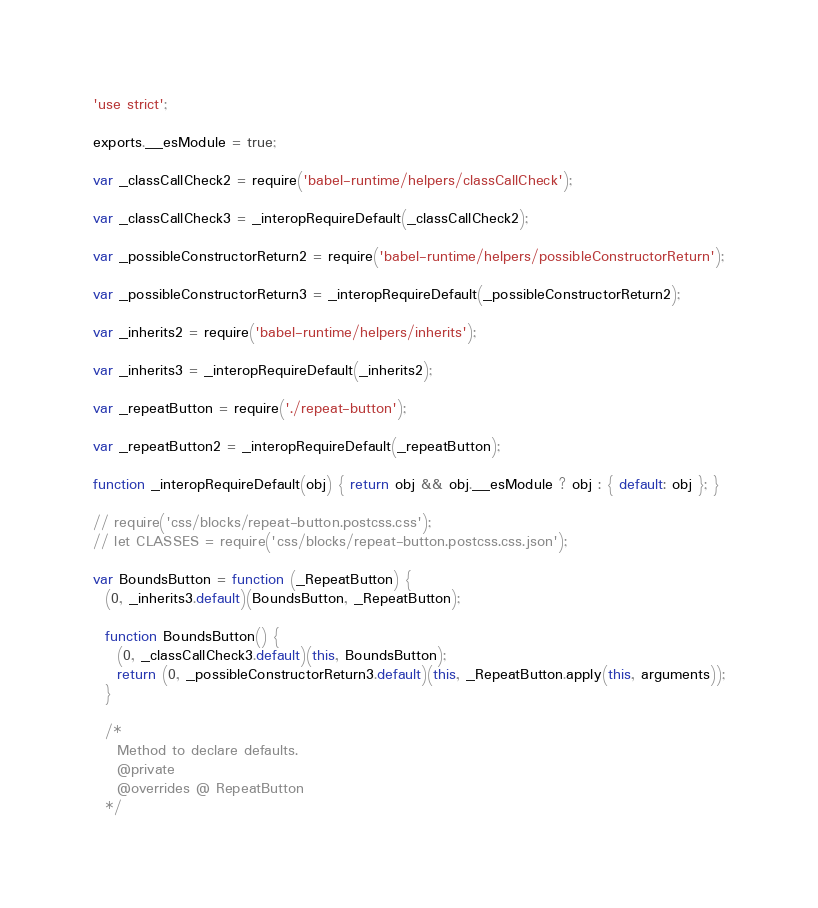Convert code to text. <code><loc_0><loc_0><loc_500><loc_500><_JavaScript_>'use strict';

exports.__esModule = true;

var _classCallCheck2 = require('babel-runtime/helpers/classCallCheck');

var _classCallCheck3 = _interopRequireDefault(_classCallCheck2);

var _possibleConstructorReturn2 = require('babel-runtime/helpers/possibleConstructorReturn');

var _possibleConstructorReturn3 = _interopRequireDefault(_possibleConstructorReturn2);

var _inherits2 = require('babel-runtime/helpers/inherits');

var _inherits3 = _interopRequireDefault(_inherits2);

var _repeatButton = require('./repeat-button');

var _repeatButton2 = _interopRequireDefault(_repeatButton);

function _interopRequireDefault(obj) { return obj && obj.__esModule ? obj : { default: obj }; }

// require('css/blocks/repeat-button.postcss.css');
// let CLASSES = require('css/blocks/repeat-button.postcss.css.json');

var BoundsButton = function (_RepeatButton) {
  (0, _inherits3.default)(BoundsButton, _RepeatButton);

  function BoundsButton() {
    (0, _classCallCheck3.default)(this, BoundsButton);
    return (0, _possibleConstructorReturn3.default)(this, _RepeatButton.apply(this, arguments));
  }

  /*
    Method to declare defaults.
    @private
    @overrides @ RepeatButton
  */
</code> 